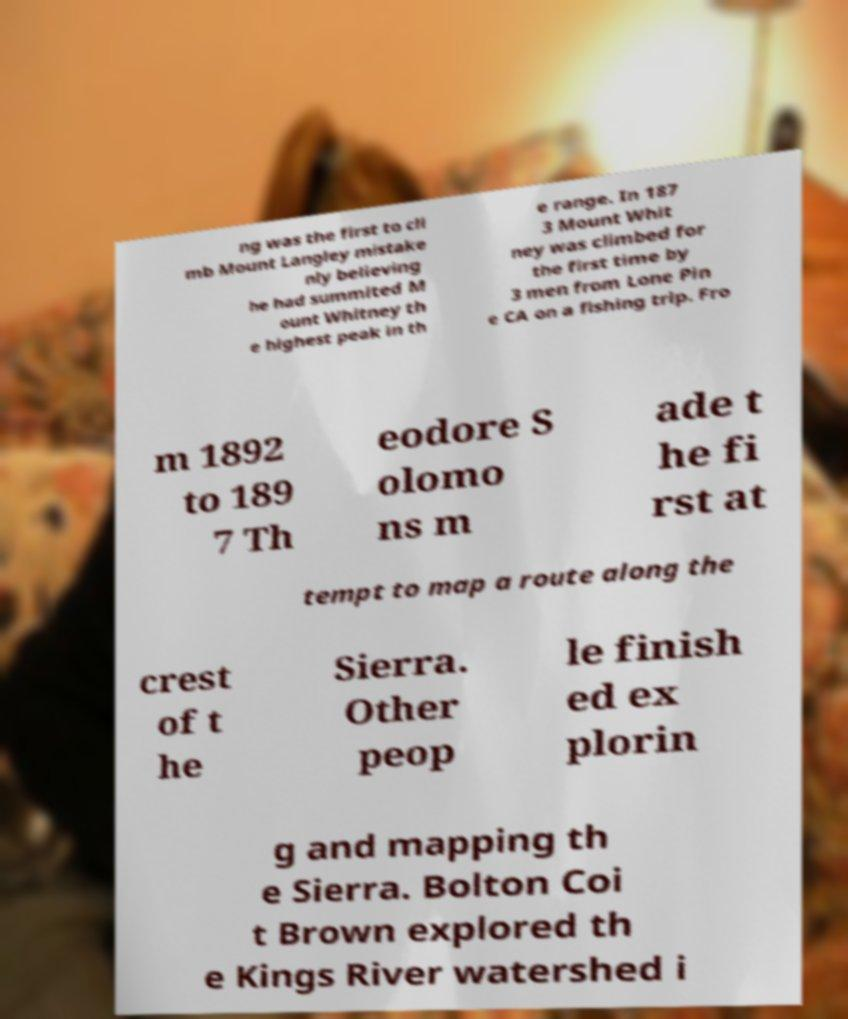I need the written content from this picture converted into text. Can you do that? ng was the first to cli mb Mount Langley mistake nly believing he had summited M ount Whitney th e highest peak in th e range. In 187 3 Mount Whit ney was climbed for the first time by 3 men from Lone Pin e CA on a fishing trip. Fro m 1892 to 189 7 Th eodore S olomo ns m ade t he fi rst at tempt to map a route along the crest of t he Sierra. Other peop le finish ed ex plorin g and mapping th e Sierra. Bolton Coi t Brown explored th e Kings River watershed i 